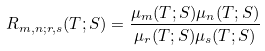Convert formula to latex. <formula><loc_0><loc_0><loc_500><loc_500>R _ { m , n ; r , s } ( T ; S ) = \frac { \mu _ { m } ( T ; S ) \mu _ { n } ( T ; S ) } { \mu _ { r } ( T ; S ) \mu _ { s } ( T ; S ) }</formula> 